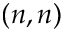<formula> <loc_0><loc_0><loc_500><loc_500>( n , n )</formula> 